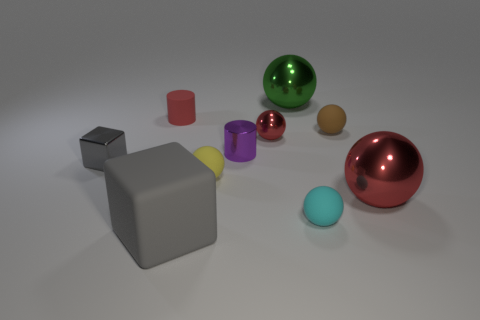What materials are used to make the objects in the scene appear as they do? The objects in the image are rendered with different finishes that contribute to their appearance. For instance, the matte texture on the red cylinder absorbs light, reducing reflectivity, while the glossy finish on the black cube and the shiny red sphere enhances reflectivity and highlights. Each material choice, whether matte, glossy, or shiny, serves to distinguish the objects visually and emphasizes their individual forms. 